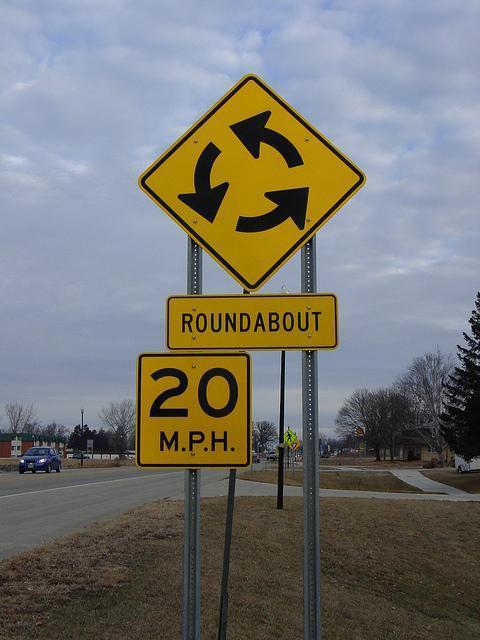How many stripes are on the road?
Give a very brief answer. 1. 